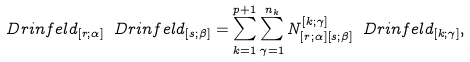<formula> <loc_0><loc_0><loc_500><loc_500>\ D r i n f e l d _ { [ r ; \alpha ] } \ D r i n f e l d _ { [ s ; \beta ] } = \sum _ { k = 1 } ^ { p + 1 } \sum _ { \gamma = 1 } ^ { n _ { k } } N _ { [ r ; \alpha ] [ s ; \beta ] } ^ { [ k ; \gamma ] } \ D r i n f e l d _ { [ k ; \gamma ] } ,</formula> 